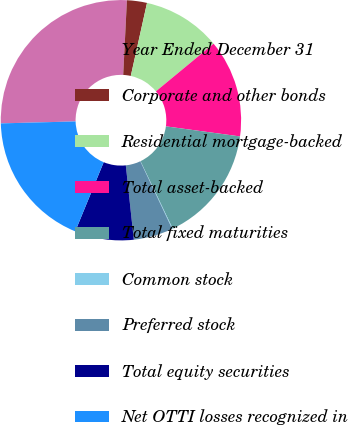Convert chart to OTSL. <chart><loc_0><loc_0><loc_500><loc_500><pie_chart><fcel>Year Ended December 31<fcel>Corporate and other bonds<fcel>Residential mortgage-backed<fcel>Total asset-backed<fcel>Total fixed maturities<fcel>Common stock<fcel>Preferred stock<fcel>Total equity securities<fcel>Net OTTI losses recognized in<nl><fcel>26.21%<fcel>2.69%<fcel>10.53%<fcel>13.14%<fcel>15.76%<fcel>0.08%<fcel>5.3%<fcel>7.92%<fcel>18.37%<nl></chart> 